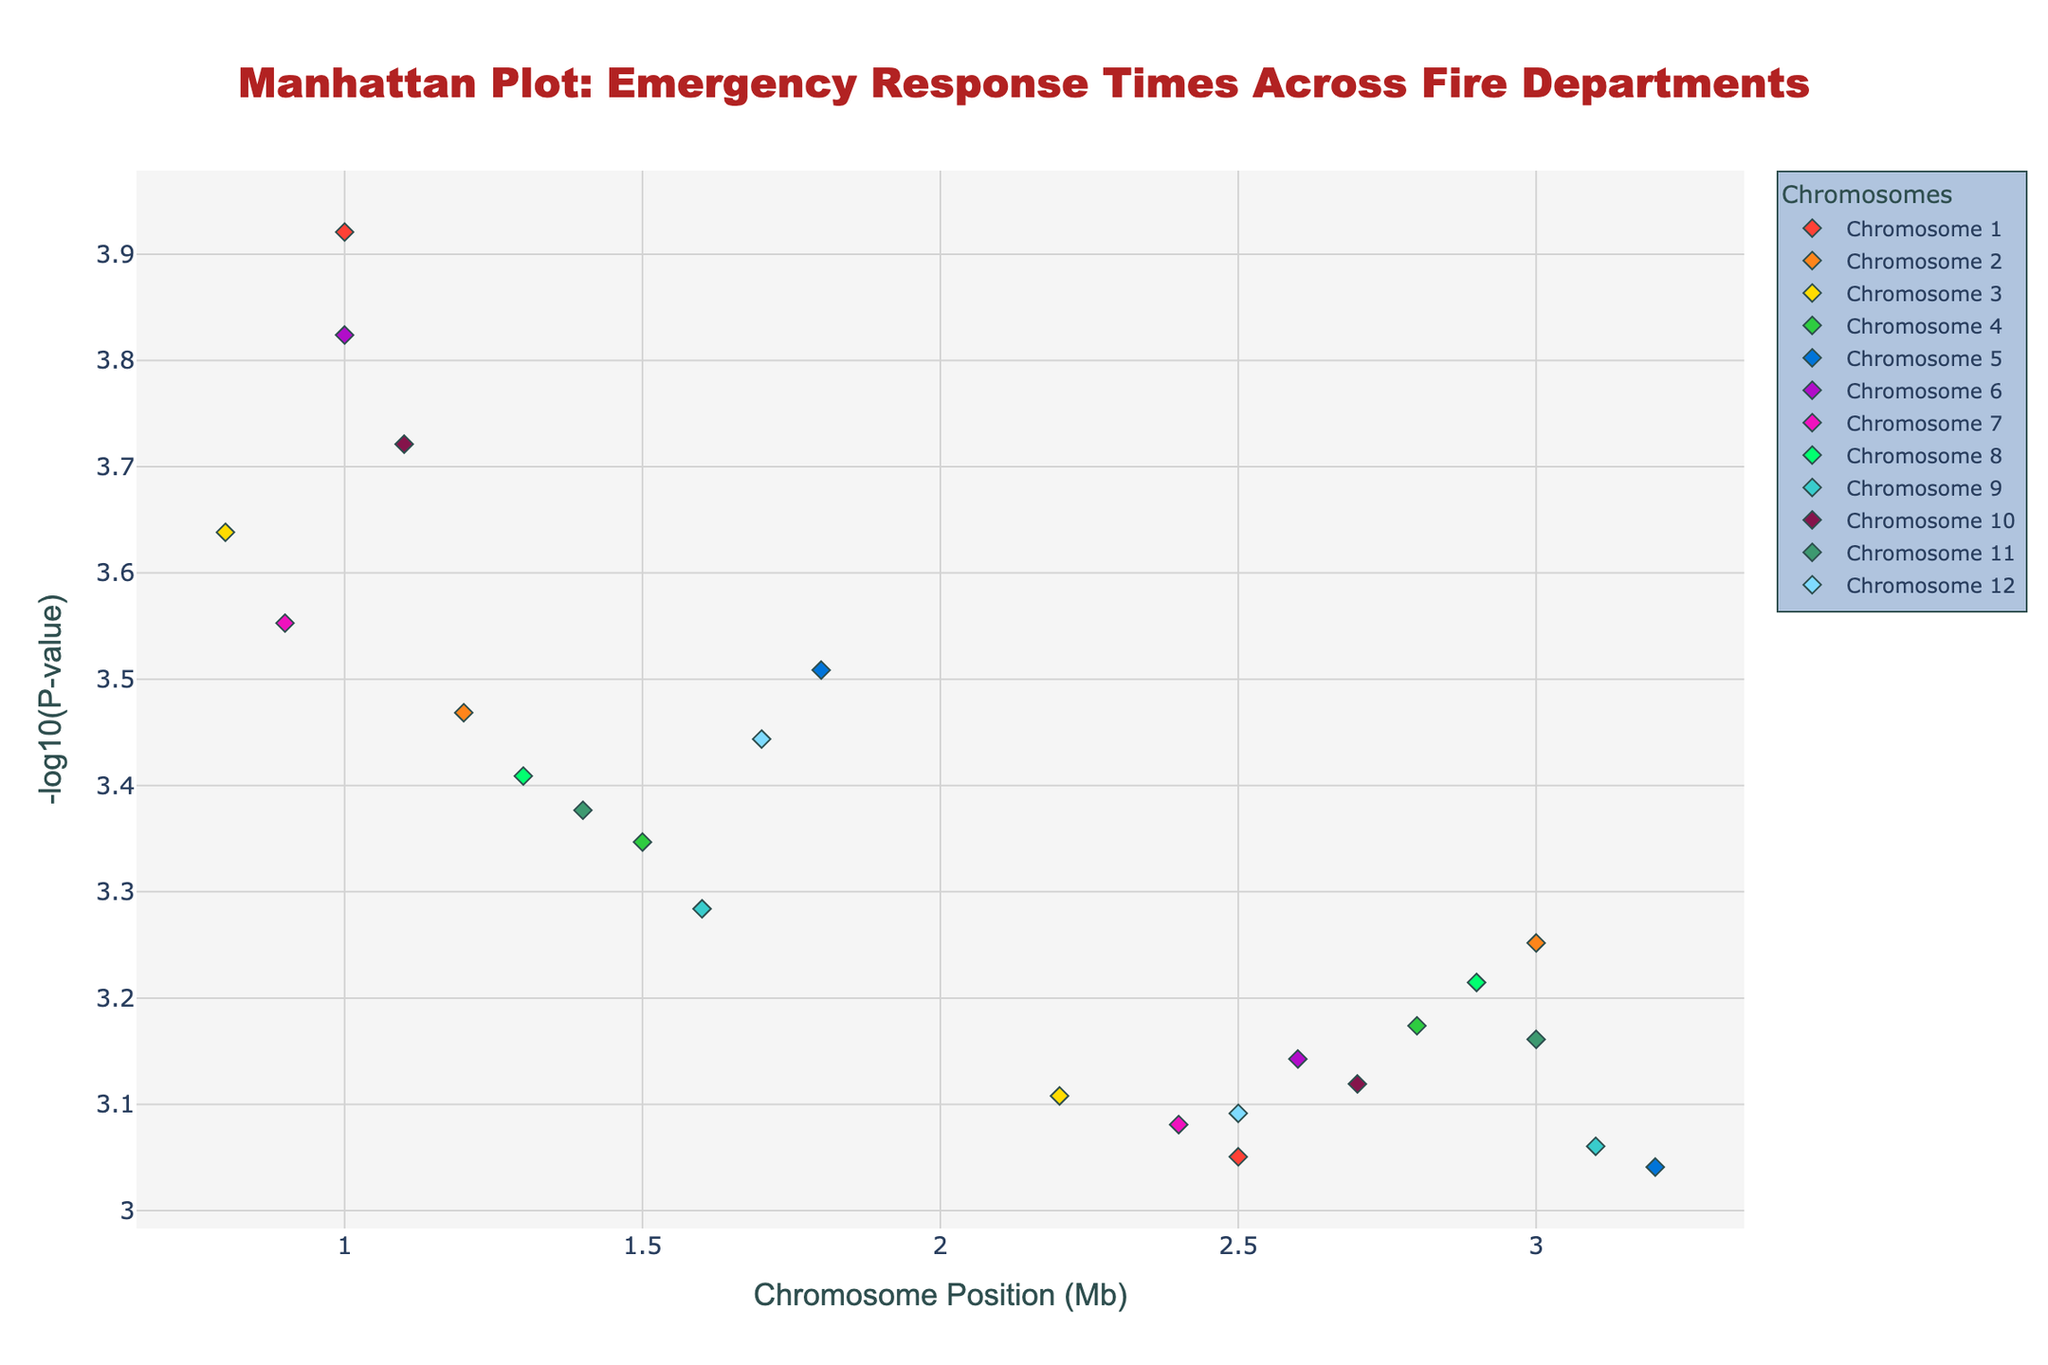How many chromosomes are represented in this plot? By observing the different chromosome labels (1 through 12) in the legend, we can see that there are 12 unique chromosomes.
Answer: 12 What is the range of the y-axis? The y-axis shows the -log10(P-value), ranging from 0 (bottom) to just above 4 (top), as inferred from the highest plotted points.
Answer: 0 to 4 Which department has the highest -log10(P-value)? Looking at the highest point on the y-axis, a Chromosome 5 data point for San Jose Fire Department stands out with the highest -log10(P) around 3.04.
Answer: San Jose Fire Department What is the relationship between the position on x-axis and the color of points? Each chromosome is represented by a different color on the plot. Points for each chromosome are clustered together and share the same color, showing positions within that chromosome.
Answer: Color groups represent chromosomes Which chromosome has the greatest variety in emergency response times? By observing the spread of points along the y-axis, Chromosome 10 has one of the widest vertical distributions from around 0.7 to 3.7 on -log10(P) scale.
Answer: Chromosome 10 How does the response time of New York City Fire Department compare with San Antonio Fire Department? New York City Fire Department point has a -log10(P) value of about 3.92, whereas San Antonio Fire Department has about 3.35. New York City has lower response time (higher -log10(P) value).
Answer: New York City Fire Department has a higher -log10(P) value Identify the departments with at least two data points. Departments like New York City Fire Department, Los Angeles County Fire Department, and San Antonio Fire Department have several points on different chromosomes.
Answer: New York City, Los Angeles County, and San Antonio What is the -log10(P-value) for Seattle Fire Department? Seattle Fire Department is a point on Chromosome 9, marked around the y-axis value of approximately 3.28.
Answer: 3.28 